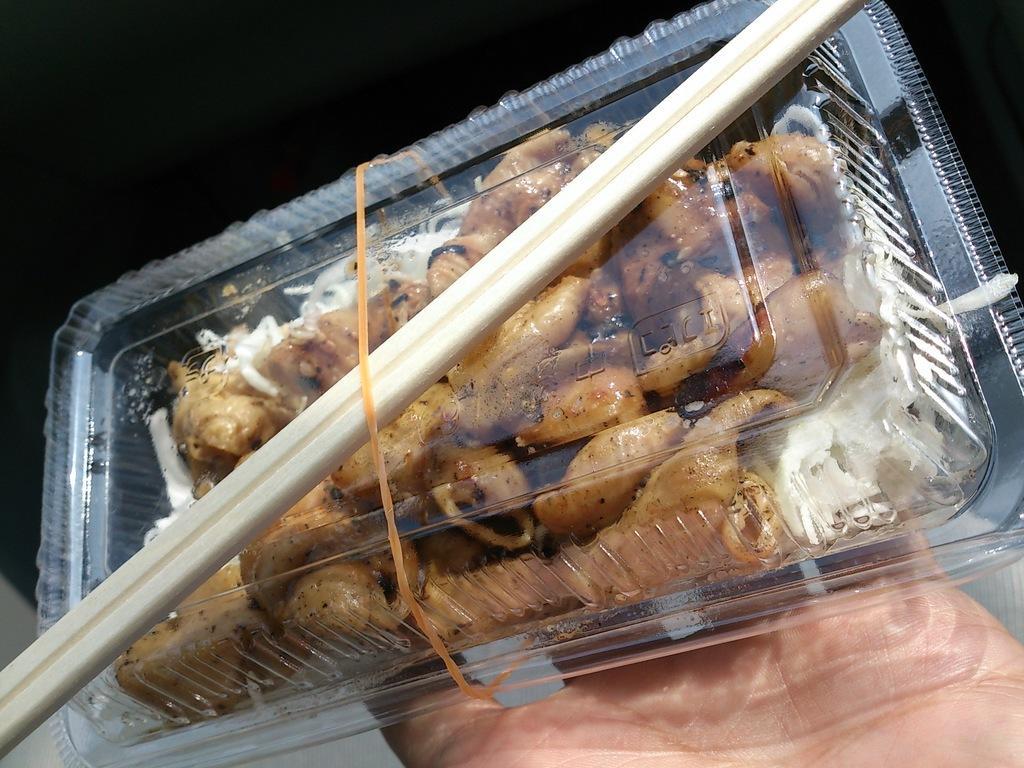Please provide a concise description of this image. In this image we can see a person's hand holding a box containing food. At the top there are chopsticks. 